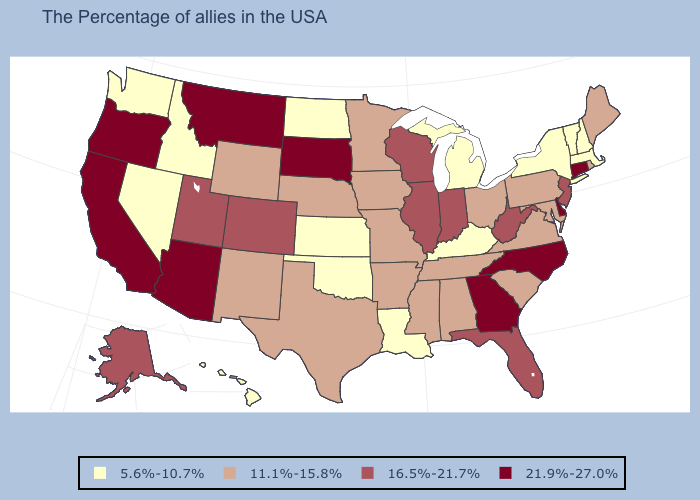Among the states that border Virginia , does Kentucky have the lowest value?
Write a very short answer. Yes. Among the states that border Minnesota , which have the highest value?
Concise answer only. South Dakota. Which states have the highest value in the USA?
Keep it brief. Connecticut, Delaware, North Carolina, Georgia, South Dakota, Montana, Arizona, California, Oregon. Does the first symbol in the legend represent the smallest category?
Keep it brief. Yes. Does Louisiana have the same value as Minnesota?
Give a very brief answer. No. Name the states that have a value in the range 21.9%-27.0%?
Short answer required. Connecticut, Delaware, North Carolina, Georgia, South Dakota, Montana, Arizona, California, Oregon. Name the states that have a value in the range 21.9%-27.0%?
Short answer required. Connecticut, Delaware, North Carolina, Georgia, South Dakota, Montana, Arizona, California, Oregon. What is the value of Vermont?
Write a very short answer. 5.6%-10.7%. What is the value of Washington?
Give a very brief answer. 5.6%-10.7%. Does Montana have the highest value in the USA?
Quick response, please. Yes. Does the first symbol in the legend represent the smallest category?
Be succinct. Yes. Which states have the lowest value in the MidWest?
Quick response, please. Michigan, Kansas, North Dakota. What is the highest value in states that border Kansas?
Write a very short answer. 16.5%-21.7%. What is the lowest value in states that border Iowa?
Short answer required. 11.1%-15.8%. Which states have the lowest value in the West?
Quick response, please. Idaho, Nevada, Washington, Hawaii. 